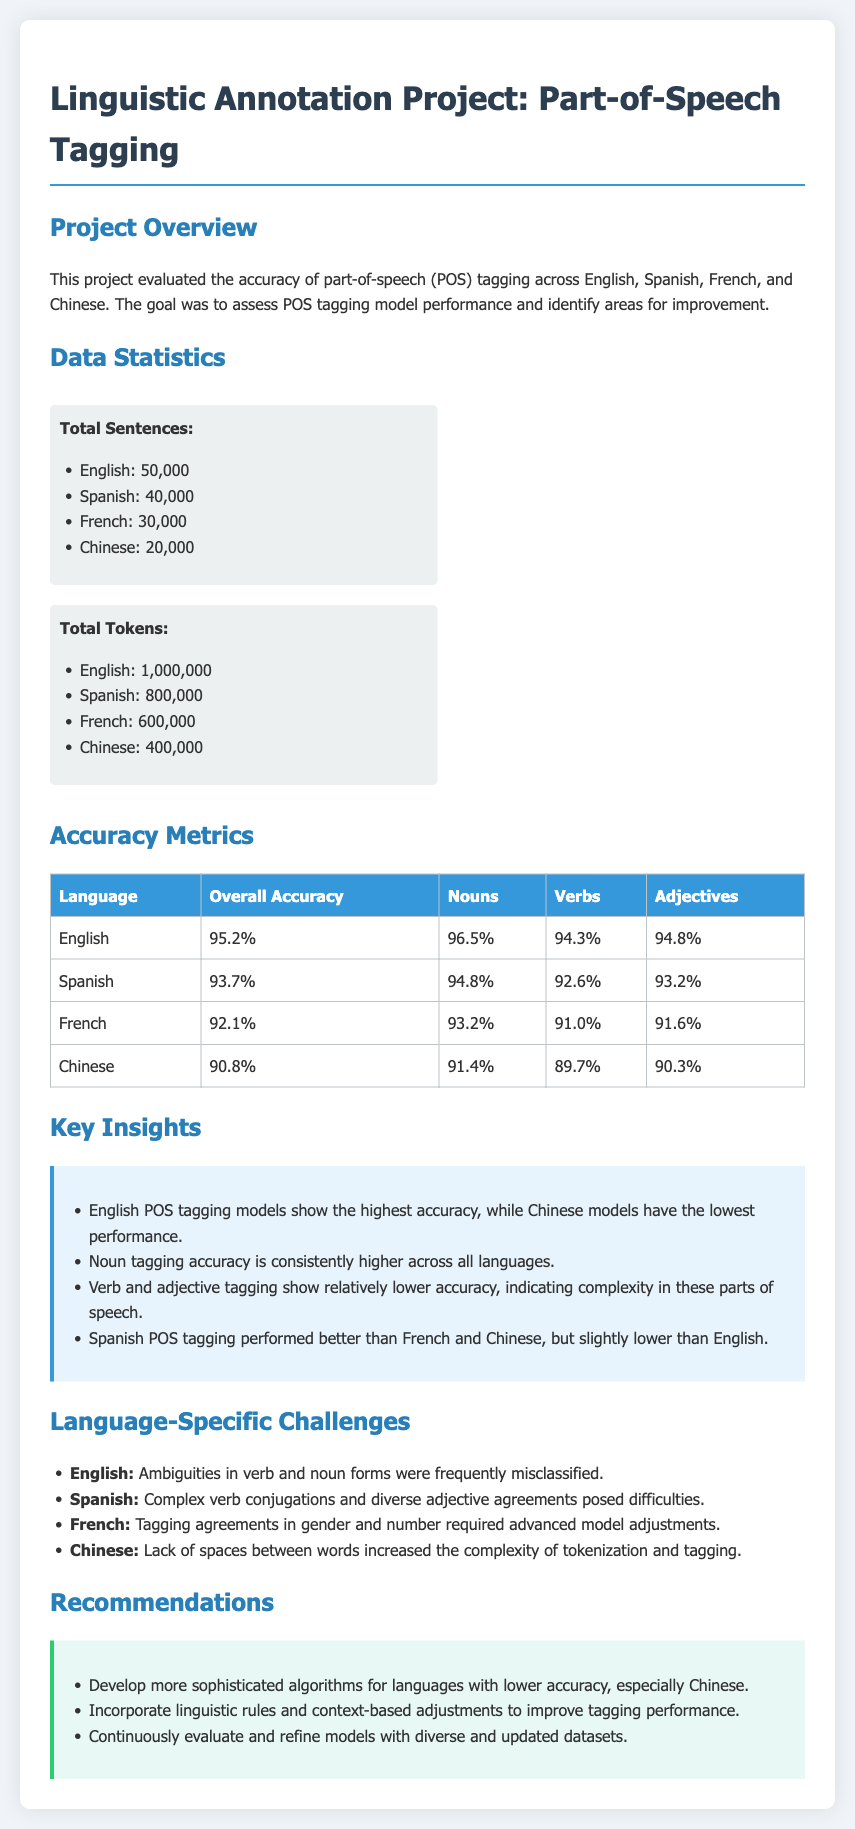what is the total number of sentences in English? The total number of sentences in English is mentioned in the data statistics section.
Answer: 50,000 what is the overall accuracy for Spanish? The overall accuracy for Spanish is provided in the accuracy metrics table.
Answer: 93.7% which language has the highest noun tagging accuracy? The noun tagging accuracy is listed by language in the accuracy metrics table; English has the highest value.
Answer: English what are the challenges for tagging in French? The document lists specific challenges for each language in a separate section; this is about French tagging agreements.
Answer: Tagging agreements in gender and number how many total tokens are there in Chinese? The total number of tokens for Chinese is provided in the data statistics section.
Answer: 400,000 what is one key insight about Spanish POS tagging? The key insights about POS tagging performance are highlighted in a specific section; Spanish is noted to be better than French and Chinese but lower than English.
Answer: Spanish POS tagging performed better than French and Chinese, but slightly lower than English which part of speech shows consistently higher accuracy across all languages? The insights section discusses the performance of different parts of speech across all languages.
Answer: Noun what is a recommendation for improving tagging performance? Recommendations for improvements are summarized in a dedicated section of the document.
Answer: Develop more sophisticated algorithms for languages with lower accuracy 